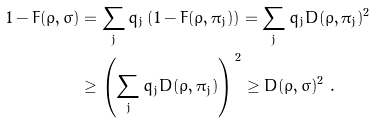Convert formula to latex. <formula><loc_0><loc_0><loc_500><loc_500>1 - F ( \rho , \sigma ) & = \sum _ { j } q _ { j } \left ( 1 - F ( \rho , \pi _ { j } ) \right ) = \sum _ { j } q _ { j } D ( \rho , \pi _ { j } ) ^ { 2 } \\ & \geq \left ( \sum _ { j } q _ { j } D ( \rho , \pi _ { j } ) \right ) ^ { \, 2 } \geq D ( \rho , \sigma ) ^ { 2 } \ .</formula> 